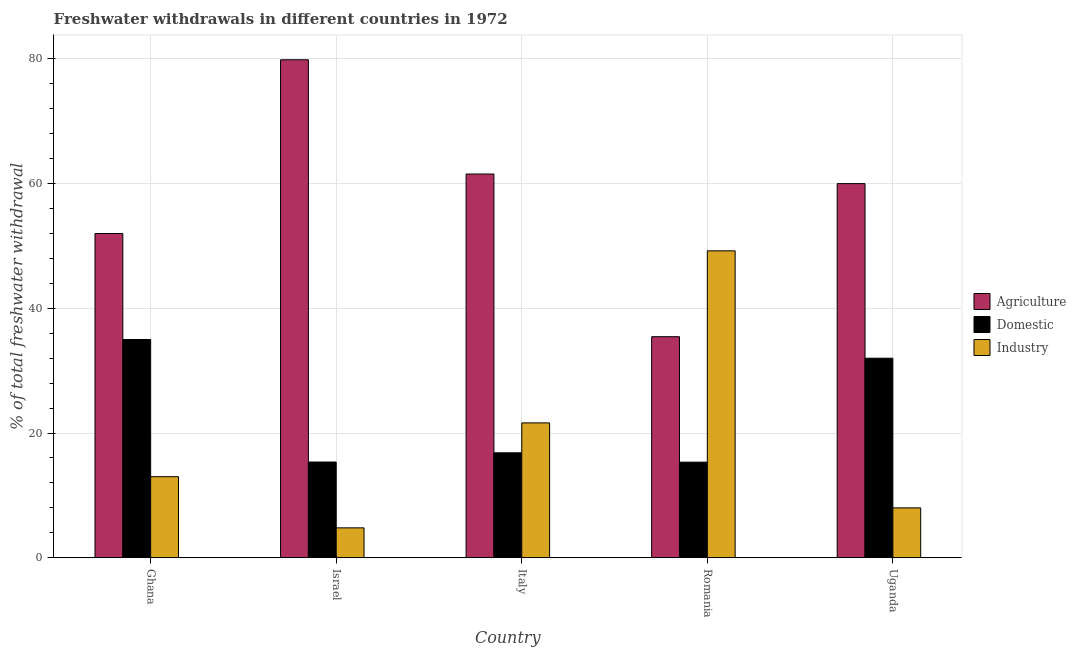How many different coloured bars are there?
Ensure brevity in your answer.  3. Are the number of bars per tick equal to the number of legend labels?
Your response must be concise. Yes. How many bars are there on the 5th tick from the left?
Give a very brief answer. 3. How many bars are there on the 1st tick from the right?
Make the answer very short. 3. What is the percentage of freshwater withdrawal for domestic purposes in Italy?
Your response must be concise. 16.83. Across all countries, what is the minimum percentage of freshwater withdrawal for industry?
Give a very brief answer. 4.79. In which country was the percentage of freshwater withdrawal for domestic purposes minimum?
Keep it short and to the point. Romania. What is the total percentage of freshwater withdrawal for agriculture in the graph?
Make the answer very short. 288.85. What is the difference between the percentage of freshwater withdrawal for industry in Romania and that in Uganda?
Keep it short and to the point. 41.22. What is the difference between the percentage of freshwater withdrawal for domestic purposes in Ghana and the percentage of freshwater withdrawal for agriculture in Romania?
Your answer should be compact. -0.45. What is the average percentage of freshwater withdrawal for domestic purposes per country?
Make the answer very short. 22.9. In how many countries, is the percentage of freshwater withdrawal for industry greater than 4 %?
Provide a short and direct response. 5. What is the ratio of the percentage of freshwater withdrawal for domestic purposes in Israel to that in Italy?
Your response must be concise. 0.91. Is the percentage of freshwater withdrawal for industry in Italy less than that in Uganda?
Give a very brief answer. No. What is the difference between the highest and the second highest percentage of freshwater withdrawal for industry?
Provide a short and direct response. 27.59. What is the difference between the highest and the lowest percentage of freshwater withdrawal for domestic purposes?
Offer a very short reply. 19.67. What does the 2nd bar from the left in Ghana represents?
Offer a terse response. Domestic. What does the 2nd bar from the right in Romania represents?
Your answer should be very brief. Domestic. How many countries are there in the graph?
Make the answer very short. 5. What is the difference between two consecutive major ticks on the Y-axis?
Your response must be concise. 20. Are the values on the major ticks of Y-axis written in scientific E-notation?
Give a very brief answer. No. Where does the legend appear in the graph?
Offer a very short reply. Center right. How are the legend labels stacked?
Your response must be concise. Vertical. What is the title of the graph?
Offer a terse response. Freshwater withdrawals in different countries in 1972. Does "Argument" appear as one of the legend labels in the graph?
Your answer should be compact. No. What is the label or title of the X-axis?
Your response must be concise. Country. What is the label or title of the Y-axis?
Offer a terse response. % of total freshwater withdrawal. What is the % of total freshwater withdrawal in Domestic in Ghana?
Make the answer very short. 35. What is the % of total freshwater withdrawal in Industry in Ghana?
Ensure brevity in your answer.  13. What is the % of total freshwater withdrawal in Agriculture in Israel?
Your answer should be very brief. 79.86. What is the % of total freshwater withdrawal of Domestic in Israel?
Offer a terse response. 15.35. What is the % of total freshwater withdrawal in Industry in Israel?
Offer a terse response. 4.79. What is the % of total freshwater withdrawal in Agriculture in Italy?
Your answer should be very brief. 61.54. What is the % of total freshwater withdrawal of Domestic in Italy?
Ensure brevity in your answer.  16.83. What is the % of total freshwater withdrawal of Industry in Italy?
Provide a short and direct response. 21.63. What is the % of total freshwater withdrawal in Agriculture in Romania?
Provide a succinct answer. 35.45. What is the % of total freshwater withdrawal in Domestic in Romania?
Your answer should be compact. 15.33. What is the % of total freshwater withdrawal of Industry in Romania?
Offer a terse response. 49.22. What is the % of total freshwater withdrawal in Agriculture in Uganda?
Ensure brevity in your answer.  60. Across all countries, what is the maximum % of total freshwater withdrawal in Agriculture?
Your response must be concise. 79.86. Across all countries, what is the maximum % of total freshwater withdrawal of Industry?
Offer a very short reply. 49.22. Across all countries, what is the minimum % of total freshwater withdrawal in Agriculture?
Your answer should be compact. 35.45. Across all countries, what is the minimum % of total freshwater withdrawal in Domestic?
Give a very brief answer. 15.33. Across all countries, what is the minimum % of total freshwater withdrawal in Industry?
Provide a succinct answer. 4.79. What is the total % of total freshwater withdrawal of Agriculture in the graph?
Provide a succinct answer. 288.85. What is the total % of total freshwater withdrawal in Domestic in the graph?
Your answer should be compact. 114.51. What is the total % of total freshwater withdrawal of Industry in the graph?
Offer a very short reply. 96.64. What is the difference between the % of total freshwater withdrawal in Agriculture in Ghana and that in Israel?
Keep it short and to the point. -27.86. What is the difference between the % of total freshwater withdrawal in Domestic in Ghana and that in Israel?
Your answer should be compact. 19.65. What is the difference between the % of total freshwater withdrawal of Industry in Ghana and that in Israel?
Offer a very short reply. 8.21. What is the difference between the % of total freshwater withdrawal in Agriculture in Ghana and that in Italy?
Your response must be concise. -9.54. What is the difference between the % of total freshwater withdrawal in Domestic in Ghana and that in Italy?
Your answer should be very brief. 18.17. What is the difference between the % of total freshwater withdrawal in Industry in Ghana and that in Italy?
Keep it short and to the point. -8.63. What is the difference between the % of total freshwater withdrawal in Agriculture in Ghana and that in Romania?
Keep it short and to the point. 16.55. What is the difference between the % of total freshwater withdrawal in Domestic in Ghana and that in Romania?
Ensure brevity in your answer.  19.67. What is the difference between the % of total freshwater withdrawal in Industry in Ghana and that in Romania?
Provide a succinct answer. -36.22. What is the difference between the % of total freshwater withdrawal in Domestic in Ghana and that in Uganda?
Your response must be concise. 3. What is the difference between the % of total freshwater withdrawal in Agriculture in Israel and that in Italy?
Offer a terse response. 18.32. What is the difference between the % of total freshwater withdrawal in Domestic in Israel and that in Italy?
Keep it short and to the point. -1.48. What is the difference between the % of total freshwater withdrawal in Industry in Israel and that in Italy?
Your answer should be very brief. -16.84. What is the difference between the % of total freshwater withdrawal in Agriculture in Israel and that in Romania?
Ensure brevity in your answer.  44.41. What is the difference between the % of total freshwater withdrawal of Industry in Israel and that in Romania?
Make the answer very short. -44.42. What is the difference between the % of total freshwater withdrawal of Agriculture in Israel and that in Uganda?
Ensure brevity in your answer.  19.86. What is the difference between the % of total freshwater withdrawal in Domestic in Israel and that in Uganda?
Ensure brevity in your answer.  -16.65. What is the difference between the % of total freshwater withdrawal of Industry in Israel and that in Uganda?
Ensure brevity in your answer.  -3.21. What is the difference between the % of total freshwater withdrawal in Agriculture in Italy and that in Romania?
Your response must be concise. 26.09. What is the difference between the % of total freshwater withdrawal in Industry in Italy and that in Romania?
Provide a succinct answer. -27.59. What is the difference between the % of total freshwater withdrawal of Agriculture in Italy and that in Uganda?
Your answer should be very brief. 1.54. What is the difference between the % of total freshwater withdrawal of Domestic in Italy and that in Uganda?
Provide a succinct answer. -15.17. What is the difference between the % of total freshwater withdrawal in Industry in Italy and that in Uganda?
Provide a short and direct response. 13.63. What is the difference between the % of total freshwater withdrawal in Agriculture in Romania and that in Uganda?
Your answer should be very brief. -24.55. What is the difference between the % of total freshwater withdrawal in Domestic in Romania and that in Uganda?
Make the answer very short. -16.67. What is the difference between the % of total freshwater withdrawal in Industry in Romania and that in Uganda?
Offer a very short reply. 41.22. What is the difference between the % of total freshwater withdrawal in Agriculture in Ghana and the % of total freshwater withdrawal in Domestic in Israel?
Give a very brief answer. 36.65. What is the difference between the % of total freshwater withdrawal in Agriculture in Ghana and the % of total freshwater withdrawal in Industry in Israel?
Your answer should be very brief. 47.2. What is the difference between the % of total freshwater withdrawal in Domestic in Ghana and the % of total freshwater withdrawal in Industry in Israel?
Provide a short and direct response. 30.2. What is the difference between the % of total freshwater withdrawal of Agriculture in Ghana and the % of total freshwater withdrawal of Domestic in Italy?
Ensure brevity in your answer.  35.17. What is the difference between the % of total freshwater withdrawal of Agriculture in Ghana and the % of total freshwater withdrawal of Industry in Italy?
Ensure brevity in your answer.  30.37. What is the difference between the % of total freshwater withdrawal in Domestic in Ghana and the % of total freshwater withdrawal in Industry in Italy?
Ensure brevity in your answer.  13.37. What is the difference between the % of total freshwater withdrawal in Agriculture in Ghana and the % of total freshwater withdrawal in Domestic in Romania?
Keep it short and to the point. 36.67. What is the difference between the % of total freshwater withdrawal in Agriculture in Ghana and the % of total freshwater withdrawal in Industry in Romania?
Your answer should be very brief. 2.78. What is the difference between the % of total freshwater withdrawal of Domestic in Ghana and the % of total freshwater withdrawal of Industry in Romania?
Your answer should be compact. -14.22. What is the difference between the % of total freshwater withdrawal in Agriculture in Ghana and the % of total freshwater withdrawal in Domestic in Uganda?
Give a very brief answer. 20. What is the difference between the % of total freshwater withdrawal in Agriculture in Israel and the % of total freshwater withdrawal in Domestic in Italy?
Make the answer very short. 63.03. What is the difference between the % of total freshwater withdrawal in Agriculture in Israel and the % of total freshwater withdrawal in Industry in Italy?
Provide a succinct answer. 58.23. What is the difference between the % of total freshwater withdrawal in Domestic in Israel and the % of total freshwater withdrawal in Industry in Italy?
Make the answer very short. -6.28. What is the difference between the % of total freshwater withdrawal of Agriculture in Israel and the % of total freshwater withdrawal of Domestic in Romania?
Offer a terse response. 64.53. What is the difference between the % of total freshwater withdrawal of Agriculture in Israel and the % of total freshwater withdrawal of Industry in Romania?
Your response must be concise. 30.64. What is the difference between the % of total freshwater withdrawal of Domestic in Israel and the % of total freshwater withdrawal of Industry in Romania?
Provide a succinct answer. -33.87. What is the difference between the % of total freshwater withdrawal of Agriculture in Israel and the % of total freshwater withdrawal of Domestic in Uganda?
Provide a short and direct response. 47.86. What is the difference between the % of total freshwater withdrawal in Agriculture in Israel and the % of total freshwater withdrawal in Industry in Uganda?
Offer a terse response. 71.86. What is the difference between the % of total freshwater withdrawal of Domestic in Israel and the % of total freshwater withdrawal of Industry in Uganda?
Your answer should be compact. 7.35. What is the difference between the % of total freshwater withdrawal of Agriculture in Italy and the % of total freshwater withdrawal of Domestic in Romania?
Ensure brevity in your answer.  46.21. What is the difference between the % of total freshwater withdrawal of Agriculture in Italy and the % of total freshwater withdrawal of Industry in Romania?
Offer a terse response. 12.32. What is the difference between the % of total freshwater withdrawal in Domestic in Italy and the % of total freshwater withdrawal in Industry in Romania?
Provide a short and direct response. -32.39. What is the difference between the % of total freshwater withdrawal of Agriculture in Italy and the % of total freshwater withdrawal of Domestic in Uganda?
Ensure brevity in your answer.  29.54. What is the difference between the % of total freshwater withdrawal in Agriculture in Italy and the % of total freshwater withdrawal in Industry in Uganda?
Your answer should be compact. 53.54. What is the difference between the % of total freshwater withdrawal in Domestic in Italy and the % of total freshwater withdrawal in Industry in Uganda?
Provide a short and direct response. 8.83. What is the difference between the % of total freshwater withdrawal in Agriculture in Romania and the % of total freshwater withdrawal in Domestic in Uganda?
Provide a succinct answer. 3.45. What is the difference between the % of total freshwater withdrawal in Agriculture in Romania and the % of total freshwater withdrawal in Industry in Uganda?
Offer a terse response. 27.45. What is the difference between the % of total freshwater withdrawal in Domestic in Romania and the % of total freshwater withdrawal in Industry in Uganda?
Your answer should be very brief. 7.33. What is the average % of total freshwater withdrawal in Agriculture per country?
Ensure brevity in your answer.  57.77. What is the average % of total freshwater withdrawal in Domestic per country?
Give a very brief answer. 22.9. What is the average % of total freshwater withdrawal in Industry per country?
Offer a very short reply. 19.33. What is the difference between the % of total freshwater withdrawal in Agriculture and % of total freshwater withdrawal in Domestic in Ghana?
Your answer should be compact. 17. What is the difference between the % of total freshwater withdrawal of Agriculture and % of total freshwater withdrawal of Industry in Ghana?
Your response must be concise. 39. What is the difference between the % of total freshwater withdrawal of Agriculture and % of total freshwater withdrawal of Domestic in Israel?
Your answer should be compact. 64.51. What is the difference between the % of total freshwater withdrawal in Agriculture and % of total freshwater withdrawal in Industry in Israel?
Make the answer very short. 75.06. What is the difference between the % of total freshwater withdrawal in Domestic and % of total freshwater withdrawal in Industry in Israel?
Provide a short and direct response. 10.55. What is the difference between the % of total freshwater withdrawal of Agriculture and % of total freshwater withdrawal of Domestic in Italy?
Give a very brief answer. 44.71. What is the difference between the % of total freshwater withdrawal in Agriculture and % of total freshwater withdrawal in Industry in Italy?
Provide a short and direct response. 39.91. What is the difference between the % of total freshwater withdrawal in Agriculture and % of total freshwater withdrawal in Domestic in Romania?
Make the answer very short. 20.12. What is the difference between the % of total freshwater withdrawal of Agriculture and % of total freshwater withdrawal of Industry in Romania?
Make the answer very short. -13.77. What is the difference between the % of total freshwater withdrawal in Domestic and % of total freshwater withdrawal in Industry in Romania?
Keep it short and to the point. -33.89. What is the difference between the % of total freshwater withdrawal in Agriculture and % of total freshwater withdrawal in Industry in Uganda?
Ensure brevity in your answer.  52. What is the ratio of the % of total freshwater withdrawal of Agriculture in Ghana to that in Israel?
Your answer should be compact. 0.65. What is the ratio of the % of total freshwater withdrawal of Domestic in Ghana to that in Israel?
Provide a succinct answer. 2.28. What is the ratio of the % of total freshwater withdrawal of Industry in Ghana to that in Israel?
Offer a terse response. 2.71. What is the ratio of the % of total freshwater withdrawal in Agriculture in Ghana to that in Italy?
Keep it short and to the point. 0.84. What is the ratio of the % of total freshwater withdrawal of Domestic in Ghana to that in Italy?
Offer a very short reply. 2.08. What is the ratio of the % of total freshwater withdrawal in Industry in Ghana to that in Italy?
Provide a succinct answer. 0.6. What is the ratio of the % of total freshwater withdrawal of Agriculture in Ghana to that in Romania?
Give a very brief answer. 1.47. What is the ratio of the % of total freshwater withdrawal of Domestic in Ghana to that in Romania?
Provide a succinct answer. 2.28. What is the ratio of the % of total freshwater withdrawal in Industry in Ghana to that in Romania?
Make the answer very short. 0.26. What is the ratio of the % of total freshwater withdrawal in Agriculture in Ghana to that in Uganda?
Offer a very short reply. 0.87. What is the ratio of the % of total freshwater withdrawal of Domestic in Ghana to that in Uganda?
Your response must be concise. 1.09. What is the ratio of the % of total freshwater withdrawal of Industry in Ghana to that in Uganda?
Ensure brevity in your answer.  1.62. What is the ratio of the % of total freshwater withdrawal in Agriculture in Israel to that in Italy?
Provide a short and direct response. 1.3. What is the ratio of the % of total freshwater withdrawal in Domestic in Israel to that in Italy?
Your answer should be compact. 0.91. What is the ratio of the % of total freshwater withdrawal of Industry in Israel to that in Italy?
Provide a short and direct response. 0.22. What is the ratio of the % of total freshwater withdrawal of Agriculture in Israel to that in Romania?
Provide a succinct answer. 2.25. What is the ratio of the % of total freshwater withdrawal in Domestic in Israel to that in Romania?
Give a very brief answer. 1. What is the ratio of the % of total freshwater withdrawal in Industry in Israel to that in Romania?
Keep it short and to the point. 0.1. What is the ratio of the % of total freshwater withdrawal in Agriculture in Israel to that in Uganda?
Your answer should be compact. 1.33. What is the ratio of the % of total freshwater withdrawal of Domestic in Israel to that in Uganda?
Keep it short and to the point. 0.48. What is the ratio of the % of total freshwater withdrawal in Industry in Israel to that in Uganda?
Provide a short and direct response. 0.6. What is the ratio of the % of total freshwater withdrawal in Agriculture in Italy to that in Romania?
Provide a succinct answer. 1.74. What is the ratio of the % of total freshwater withdrawal of Domestic in Italy to that in Romania?
Provide a succinct answer. 1.1. What is the ratio of the % of total freshwater withdrawal in Industry in Italy to that in Romania?
Provide a short and direct response. 0.44. What is the ratio of the % of total freshwater withdrawal in Agriculture in Italy to that in Uganda?
Make the answer very short. 1.03. What is the ratio of the % of total freshwater withdrawal of Domestic in Italy to that in Uganda?
Your answer should be very brief. 0.53. What is the ratio of the % of total freshwater withdrawal of Industry in Italy to that in Uganda?
Ensure brevity in your answer.  2.7. What is the ratio of the % of total freshwater withdrawal of Agriculture in Romania to that in Uganda?
Provide a succinct answer. 0.59. What is the ratio of the % of total freshwater withdrawal of Domestic in Romania to that in Uganda?
Provide a succinct answer. 0.48. What is the ratio of the % of total freshwater withdrawal of Industry in Romania to that in Uganda?
Offer a very short reply. 6.15. What is the difference between the highest and the second highest % of total freshwater withdrawal in Agriculture?
Provide a short and direct response. 18.32. What is the difference between the highest and the second highest % of total freshwater withdrawal of Industry?
Your answer should be compact. 27.59. What is the difference between the highest and the lowest % of total freshwater withdrawal of Agriculture?
Your answer should be compact. 44.41. What is the difference between the highest and the lowest % of total freshwater withdrawal of Domestic?
Offer a very short reply. 19.67. What is the difference between the highest and the lowest % of total freshwater withdrawal of Industry?
Provide a succinct answer. 44.42. 